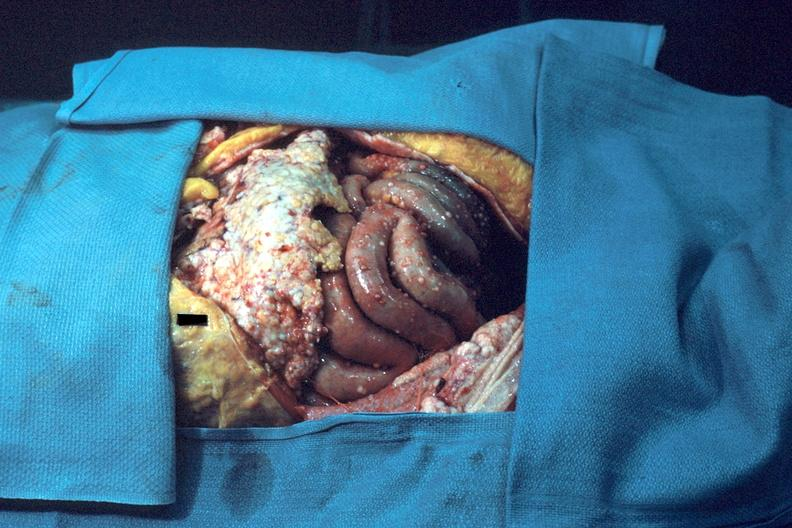what is present?
Answer the question using a single word or phrase. Peritoneum 